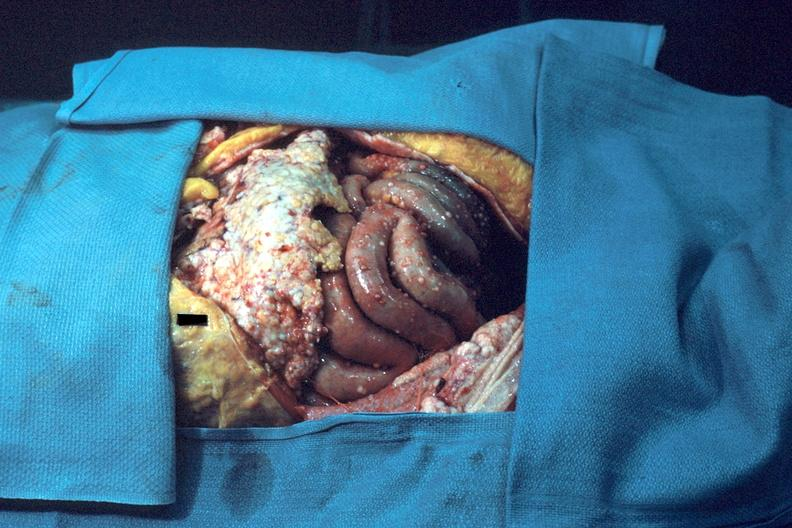what is present?
Answer the question using a single word or phrase. Peritoneum 